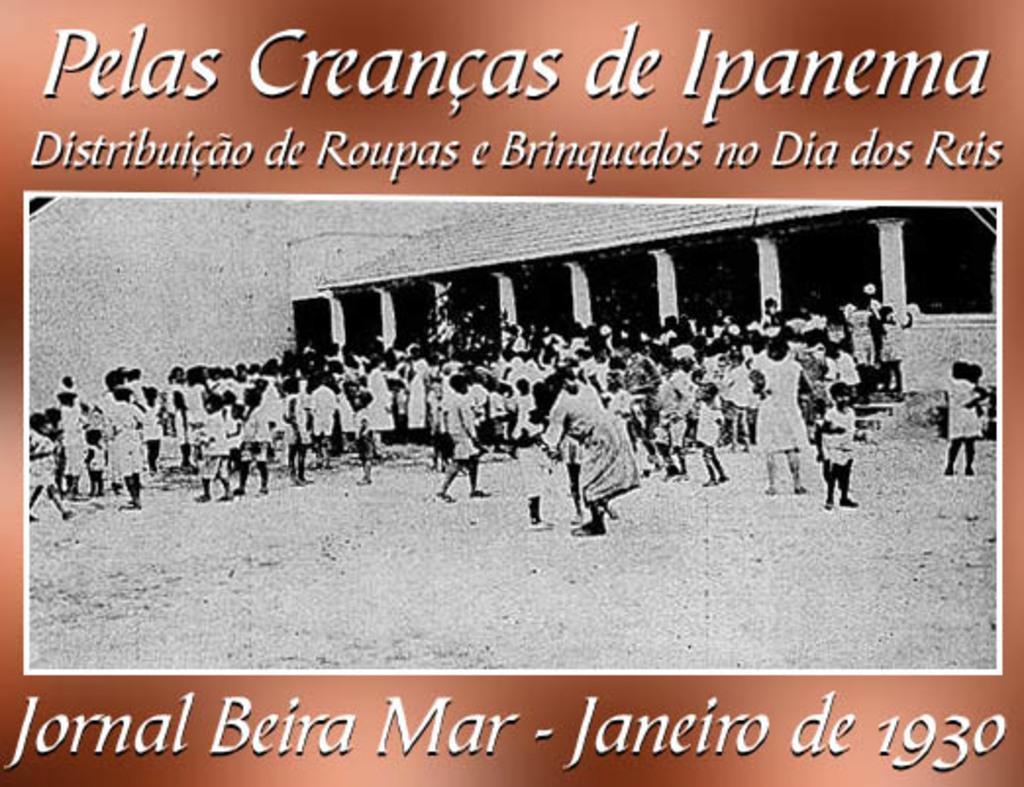In one or two sentences, can you explain what this image depicts? In the image in the center we can see one poster. On the poster,there is a building,wall,roof,pillars and few people were standing. And we can see something written on the poster. 